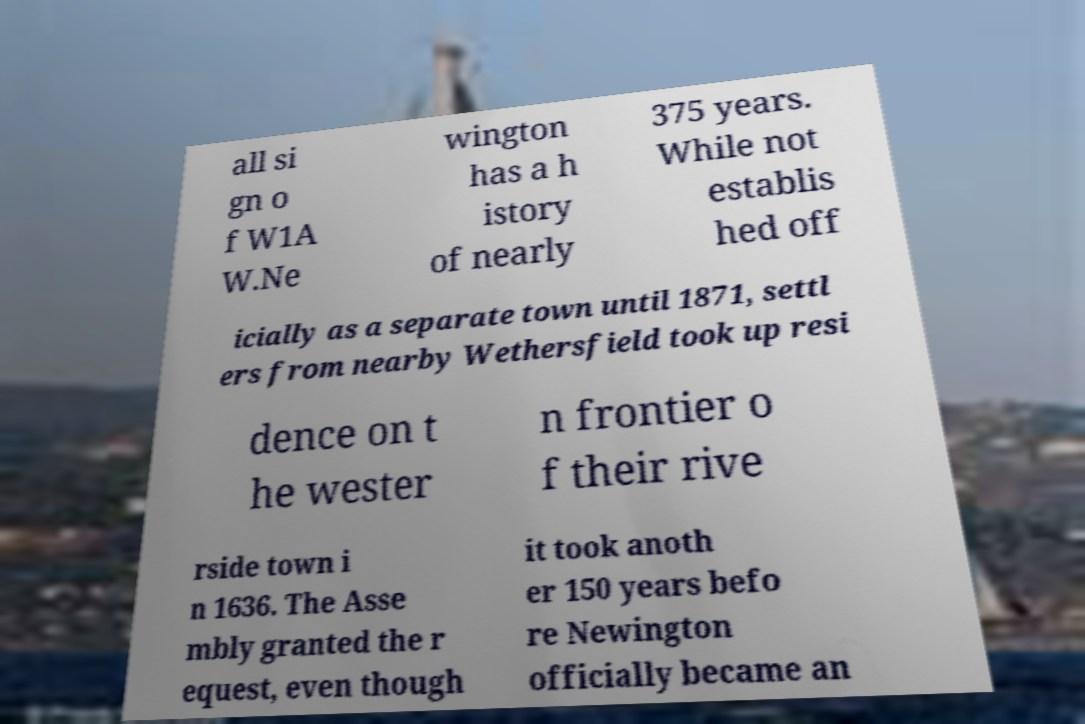Could you extract and type out the text from this image? all si gn o f W1A W.Ne wington has a h istory of nearly 375 years. While not establis hed off icially as a separate town until 1871, settl ers from nearby Wethersfield took up resi dence on t he wester n frontier o f their rive rside town i n 1636. The Asse mbly granted the r equest, even though it took anoth er 150 years befo re Newington officially became an 